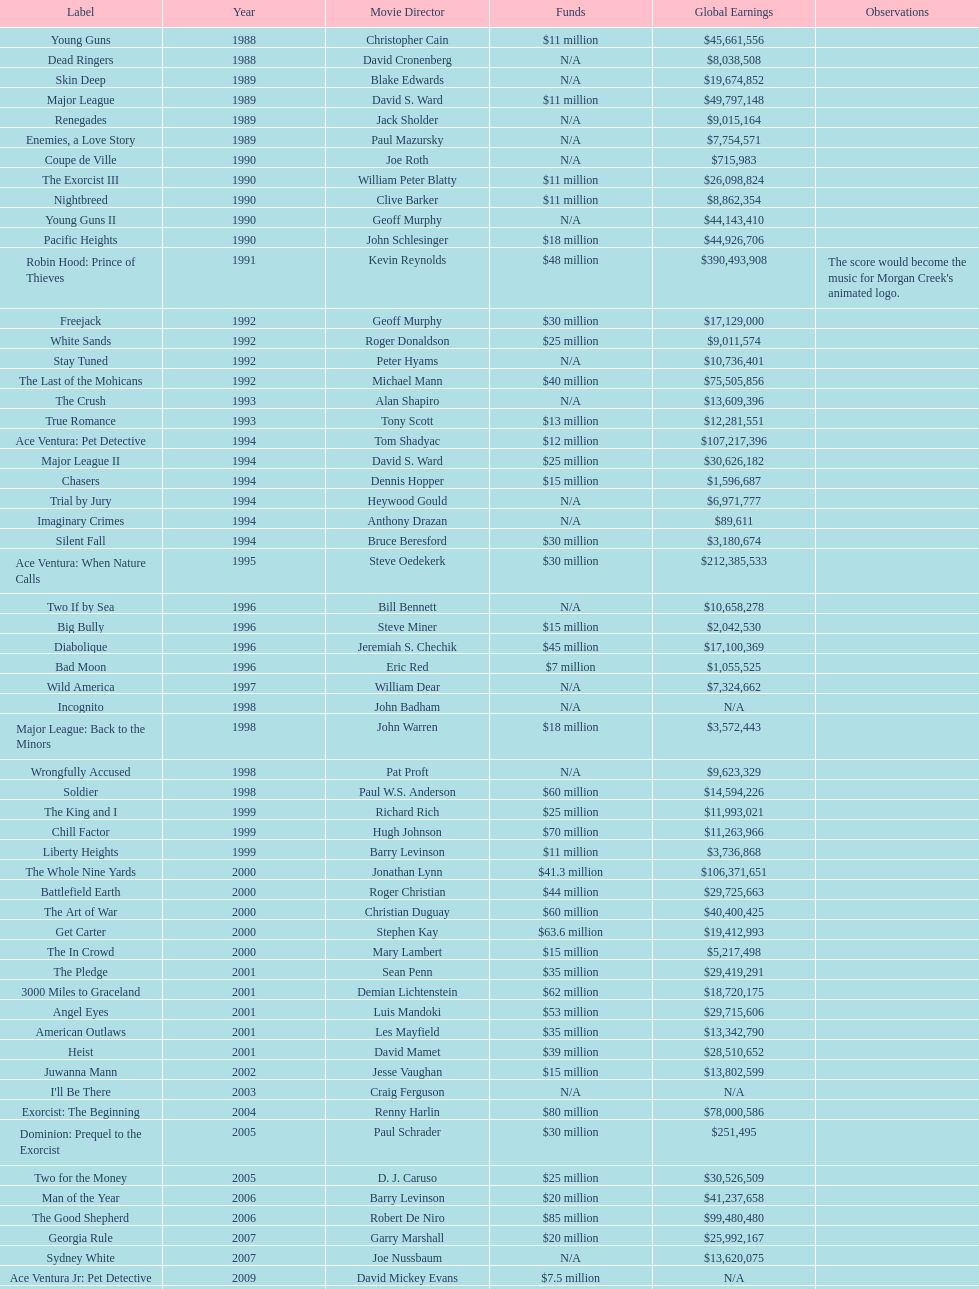What movie came out after bad moon? Wild America. 